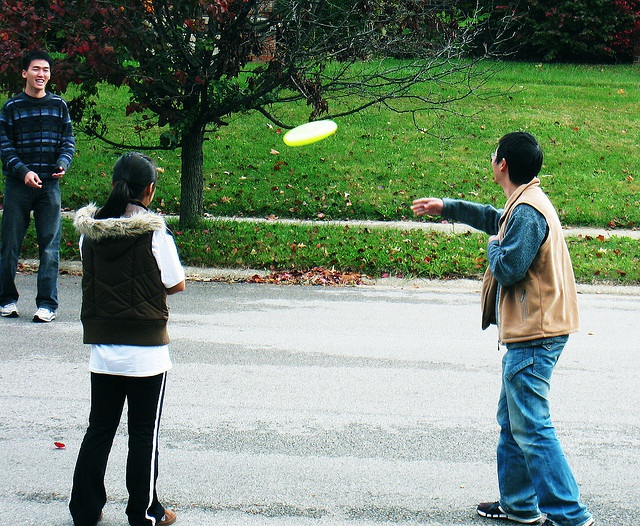Describe the objects in this image and their specific colors. I can see people in black, blue, teal, and ivory tones, people in black, white, gray, and lightblue tones, people in black, navy, blue, and lightgray tones, and frisbee in black, ivory, yellow, and khaki tones in this image. 